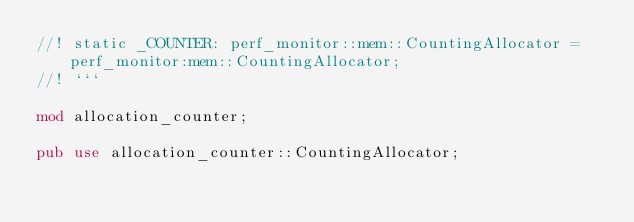Convert code to text. <code><loc_0><loc_0><loc_500><loc_500><_Rust_>//! static _COUNTER: perf_monitor::mem::CountingAllocator = perf_monitor:mem::CountingAllocator;
//! ```

mod allocation_counter;

pub use allocation_counter::CountingAllocator;
</code> 